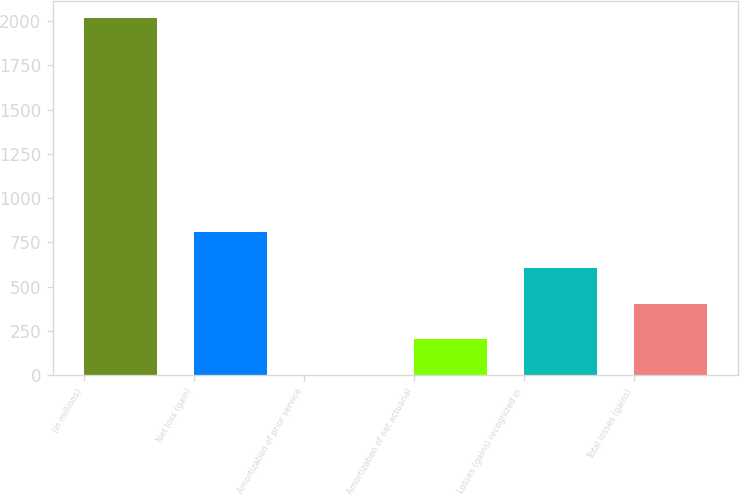Convert chart to OTSL. <chart><loc_0><loc_0><loc_500><loc_500><bar_chart><fcel>(in millions)<fcel>Net loss (gain)<fcel>Amortization of prior service<fcel>Amortization of net actuarial<fcel>Losses (gains) recognized in<fcel>Total losses (gains)<nl><fcel>2014<fcel>806.2<fcel>1<fcel>202.3<fcel>604.9<fcel>403.6<nl></chart> 